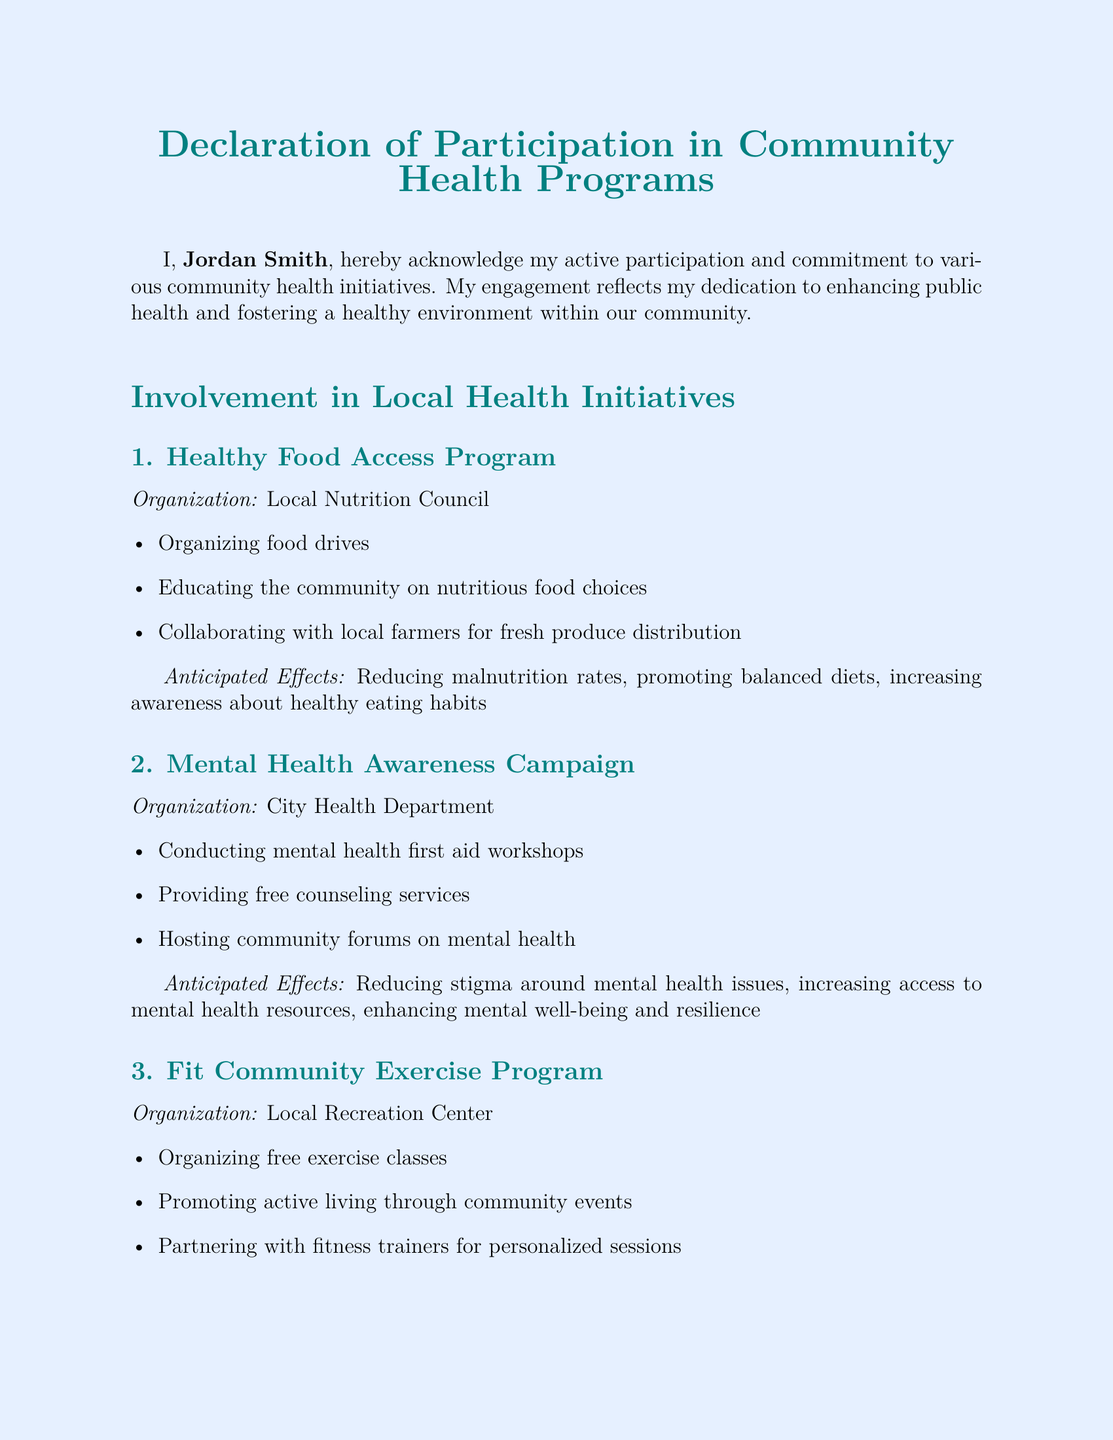What is the name of the individual making the declaration? The name of the individual is stated at the beginning of the document as Jordan Smith.
Answer: Jordan Smith When was the declaration signed? The date is provided at the end of the document, indicating when the declaration was signed.
Answer: October 12, 2023 What program is associated with the Local Nutrition Council? The program mentioned is specifically noted under involvement in local health initiatives related to the organization.
Answer: Healthy Food Access Program What type of workshops are conducted in the Mental Health Awareness Campaign? The document mentions specific types of workshops conducted as part of the initiatives.
Answer: Mental health first aid workshops What is one anticipated effect of the Fit Community Exercise Program? This effect is directly listed under the anticipated outcomes of the exercise program.
Answer: Improving physical fitness Which organization conducts the Mental Health Awareness Campaign? The relevant organization is identified within the section describing the campaign.
Answer: City Health Department What is one activity included in the Healthy Food Access Program? The activities are outlined in the corresponding section of the document.
Answer: Organizing food drives What is the primary goal of participating in these programs? The document conveys the intent and goal of the individual’s involvement.
Answer: Contribute significantly to the well-being and health of our community 